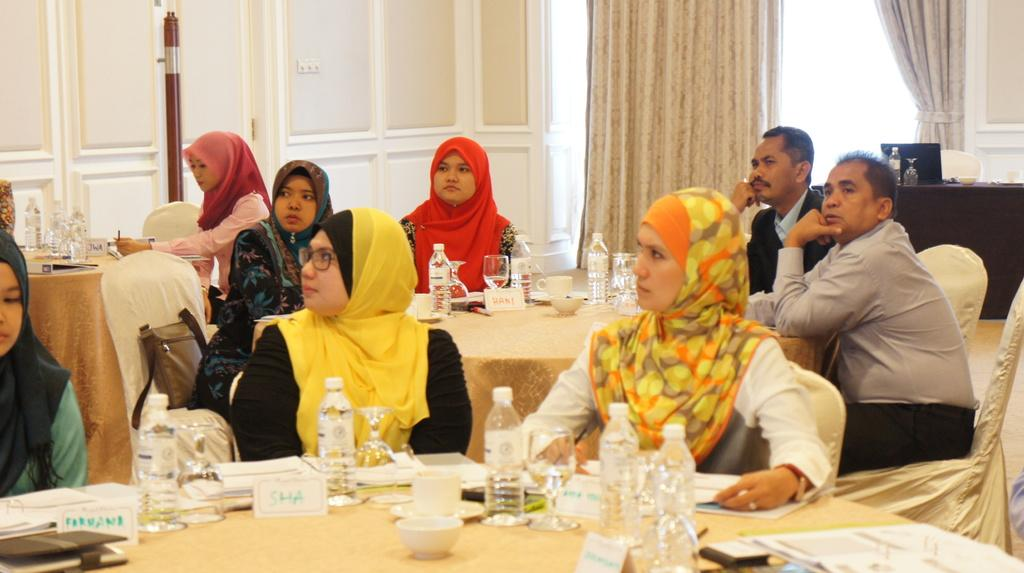What are the people in the image doing? The people in the image are sitting on chairs. What can be seen on the table in the image? There is a water bottle, a cup, and pamphlets on the table. Is there a band playing in the middle of the image? No, there is no band present in the image. 